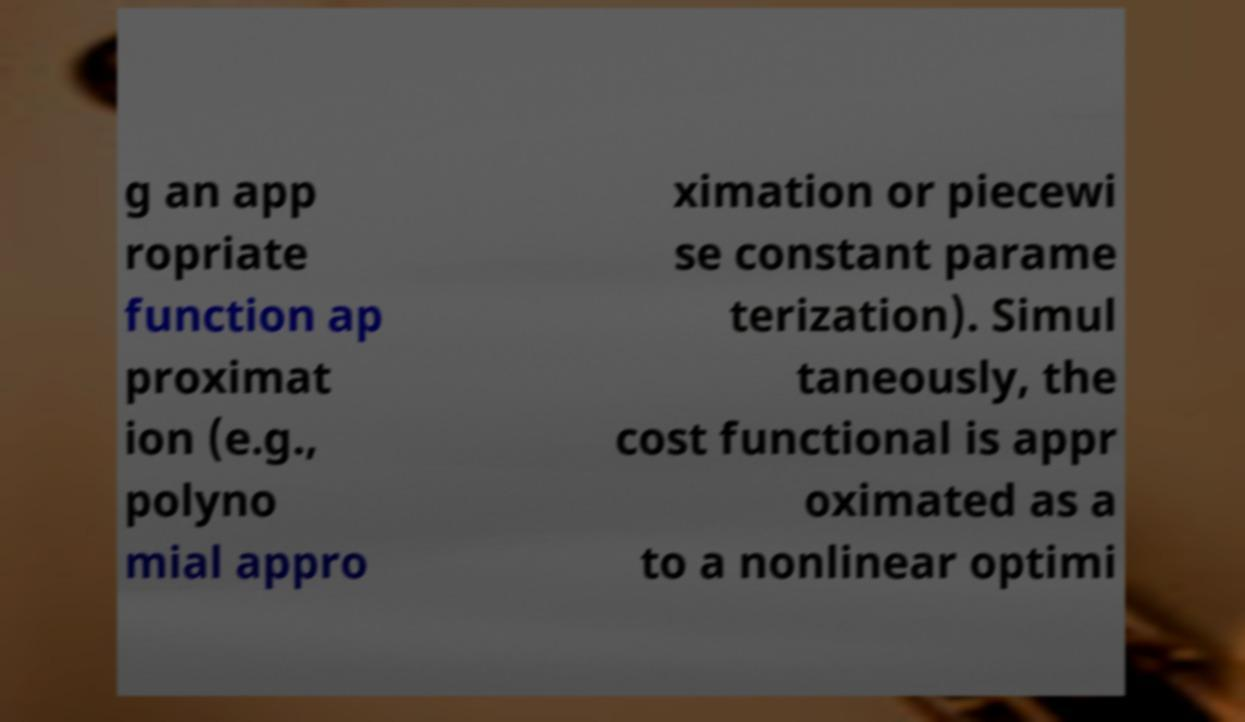There's text embedded in this image that I need extracted. Can you transcribe it verbatim? g an app ropriate function ap proximat ion (e.g., polyno mial appro ximation or piecewi se constant parame terization). Simul taneously, the cost functional is appr oximated as a to a nonlinear optimi 